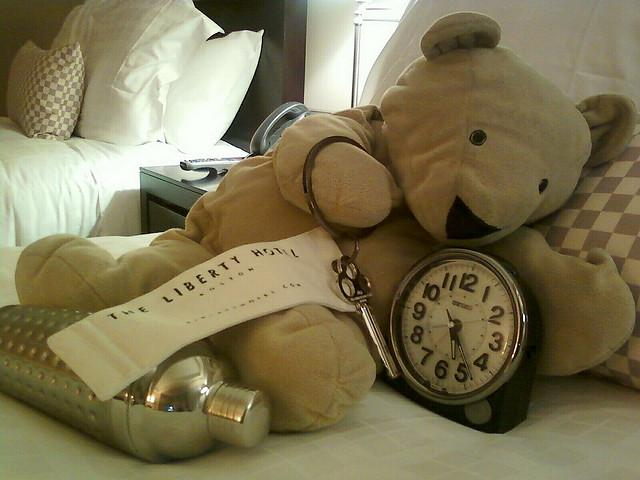What is hanging from the bear's wrist? Please explain your reasoning. key. A plush animal has a silver key hanging near it. 